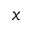<formula> <loc_0><loc_0><loc_500><loc_500>x</formula> 